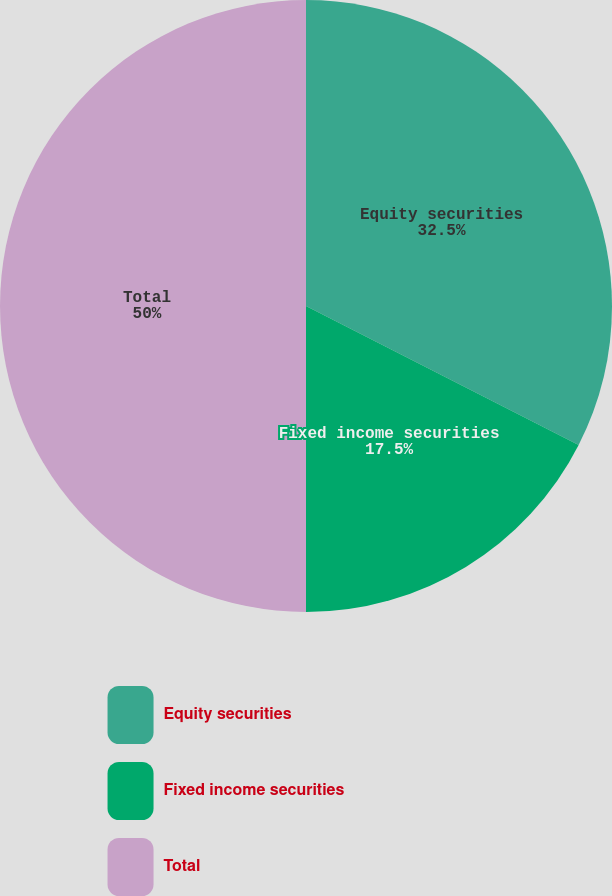<chart> <loc_0><loc_0><loc_500><loc_500><pie_chart><fcel>Equity securities<fcel>Fixed income securities<fcel>Total<nl><fcel>32.5%<fcel>17.5%<fcel>50.0%<nl></chart> 